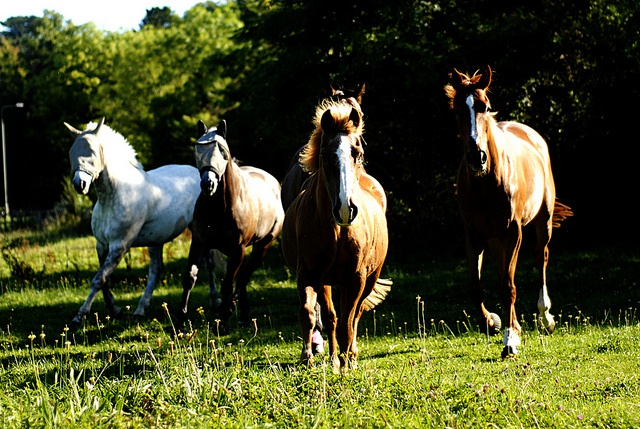Describe the objects in this image and their specific colors. I can see horse in white, black, ivory, khaki, and orange tones, horse in white, black, ivory, khaki, and orange tones, horse in white, black, gray, and blue tones, and horse in white, black, ivory, and tan tones in this image. 